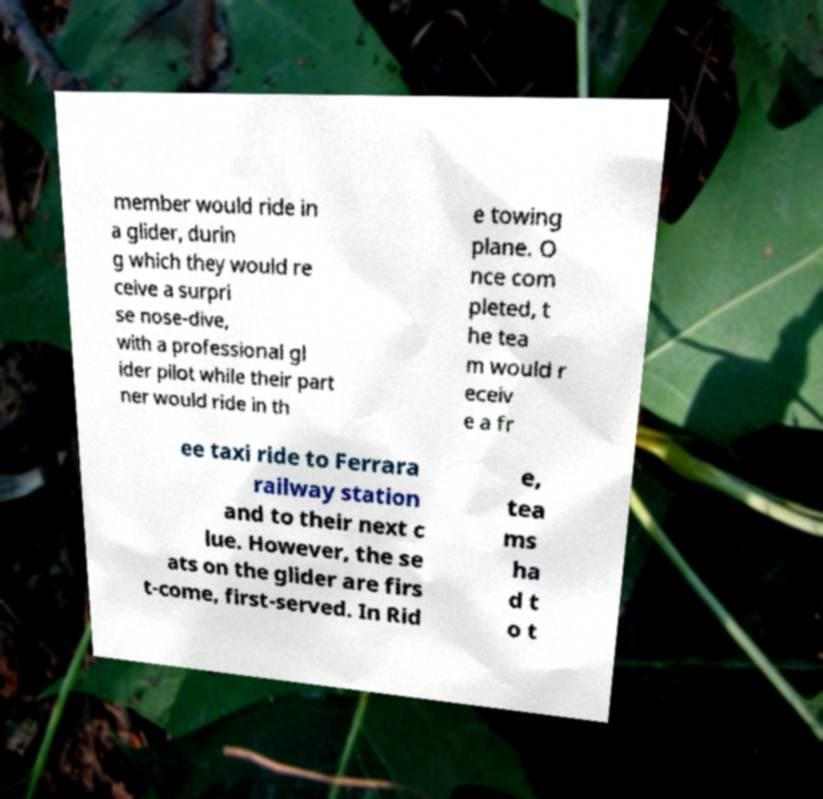There's text embedded in this image that I need extracted. Can you transcribe it verbatim? member would ride in a glider, durin g which they would re ceive a surpri se nose-dive, with a professional gl ider pilot while their part ner would ride in th e towing plane. O nce com pleted, t he tea m would r eceiv e a fr ee taxi ride to Ferrara railway station and to their next c lue. However, the se ats on the glider are firs t-come, first-served. In Rid e, tea ms ha d t o t 